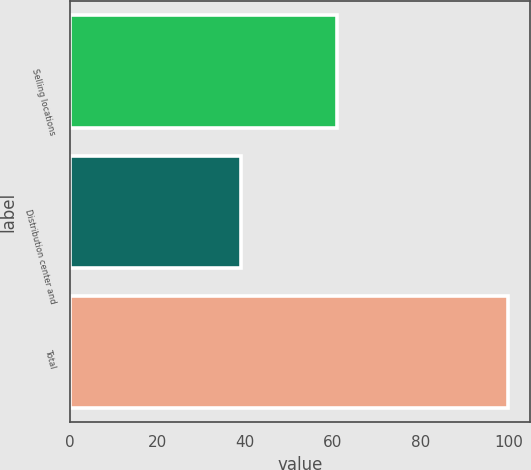Convert chart. <chart><loc_0><loc_0><loc_500><loc_500><bar_chart><fcel>Selling locations<fcel>Distribution center and<fcel>Total<nl><fcel>61<fcel>39<fcel>100<nl></chart> 